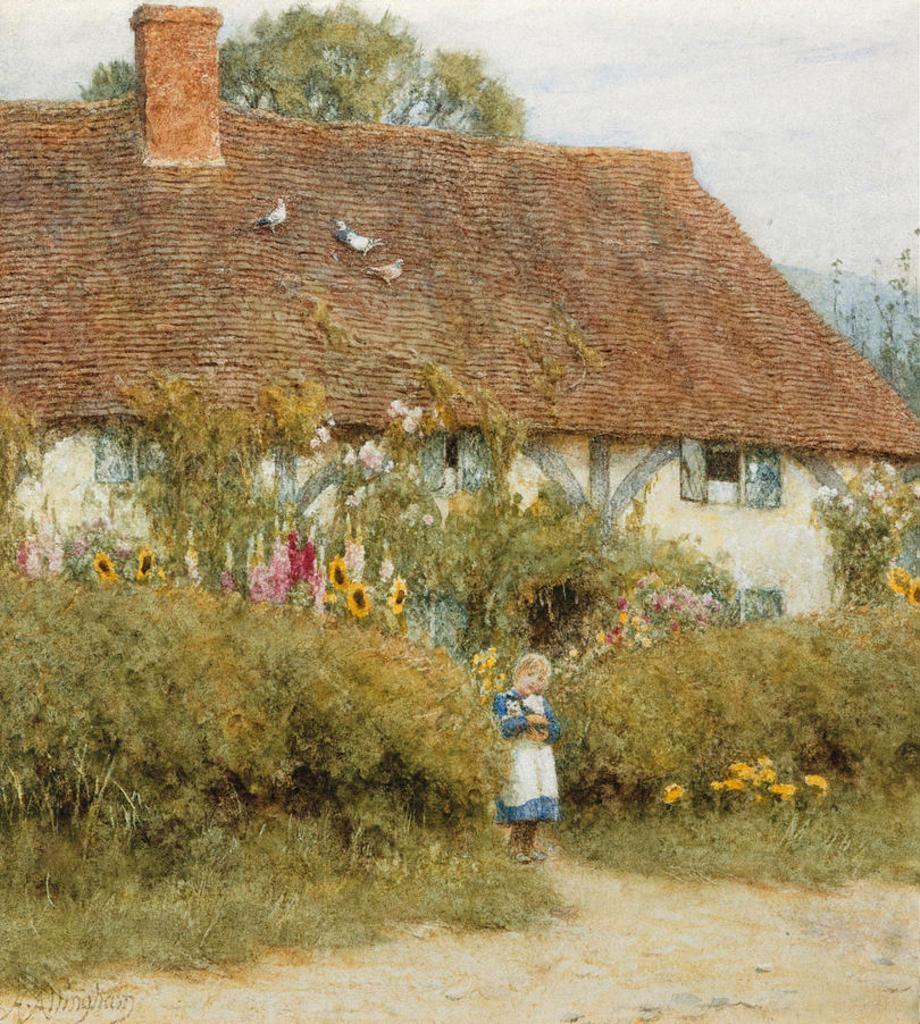Can you describe this image briefly? In this image I see a house over here and I see the plants and I see a girl over here and I see the birds over here and in the background I see the sky and I see the trees and I see few flowers and I see the watermark over here. 